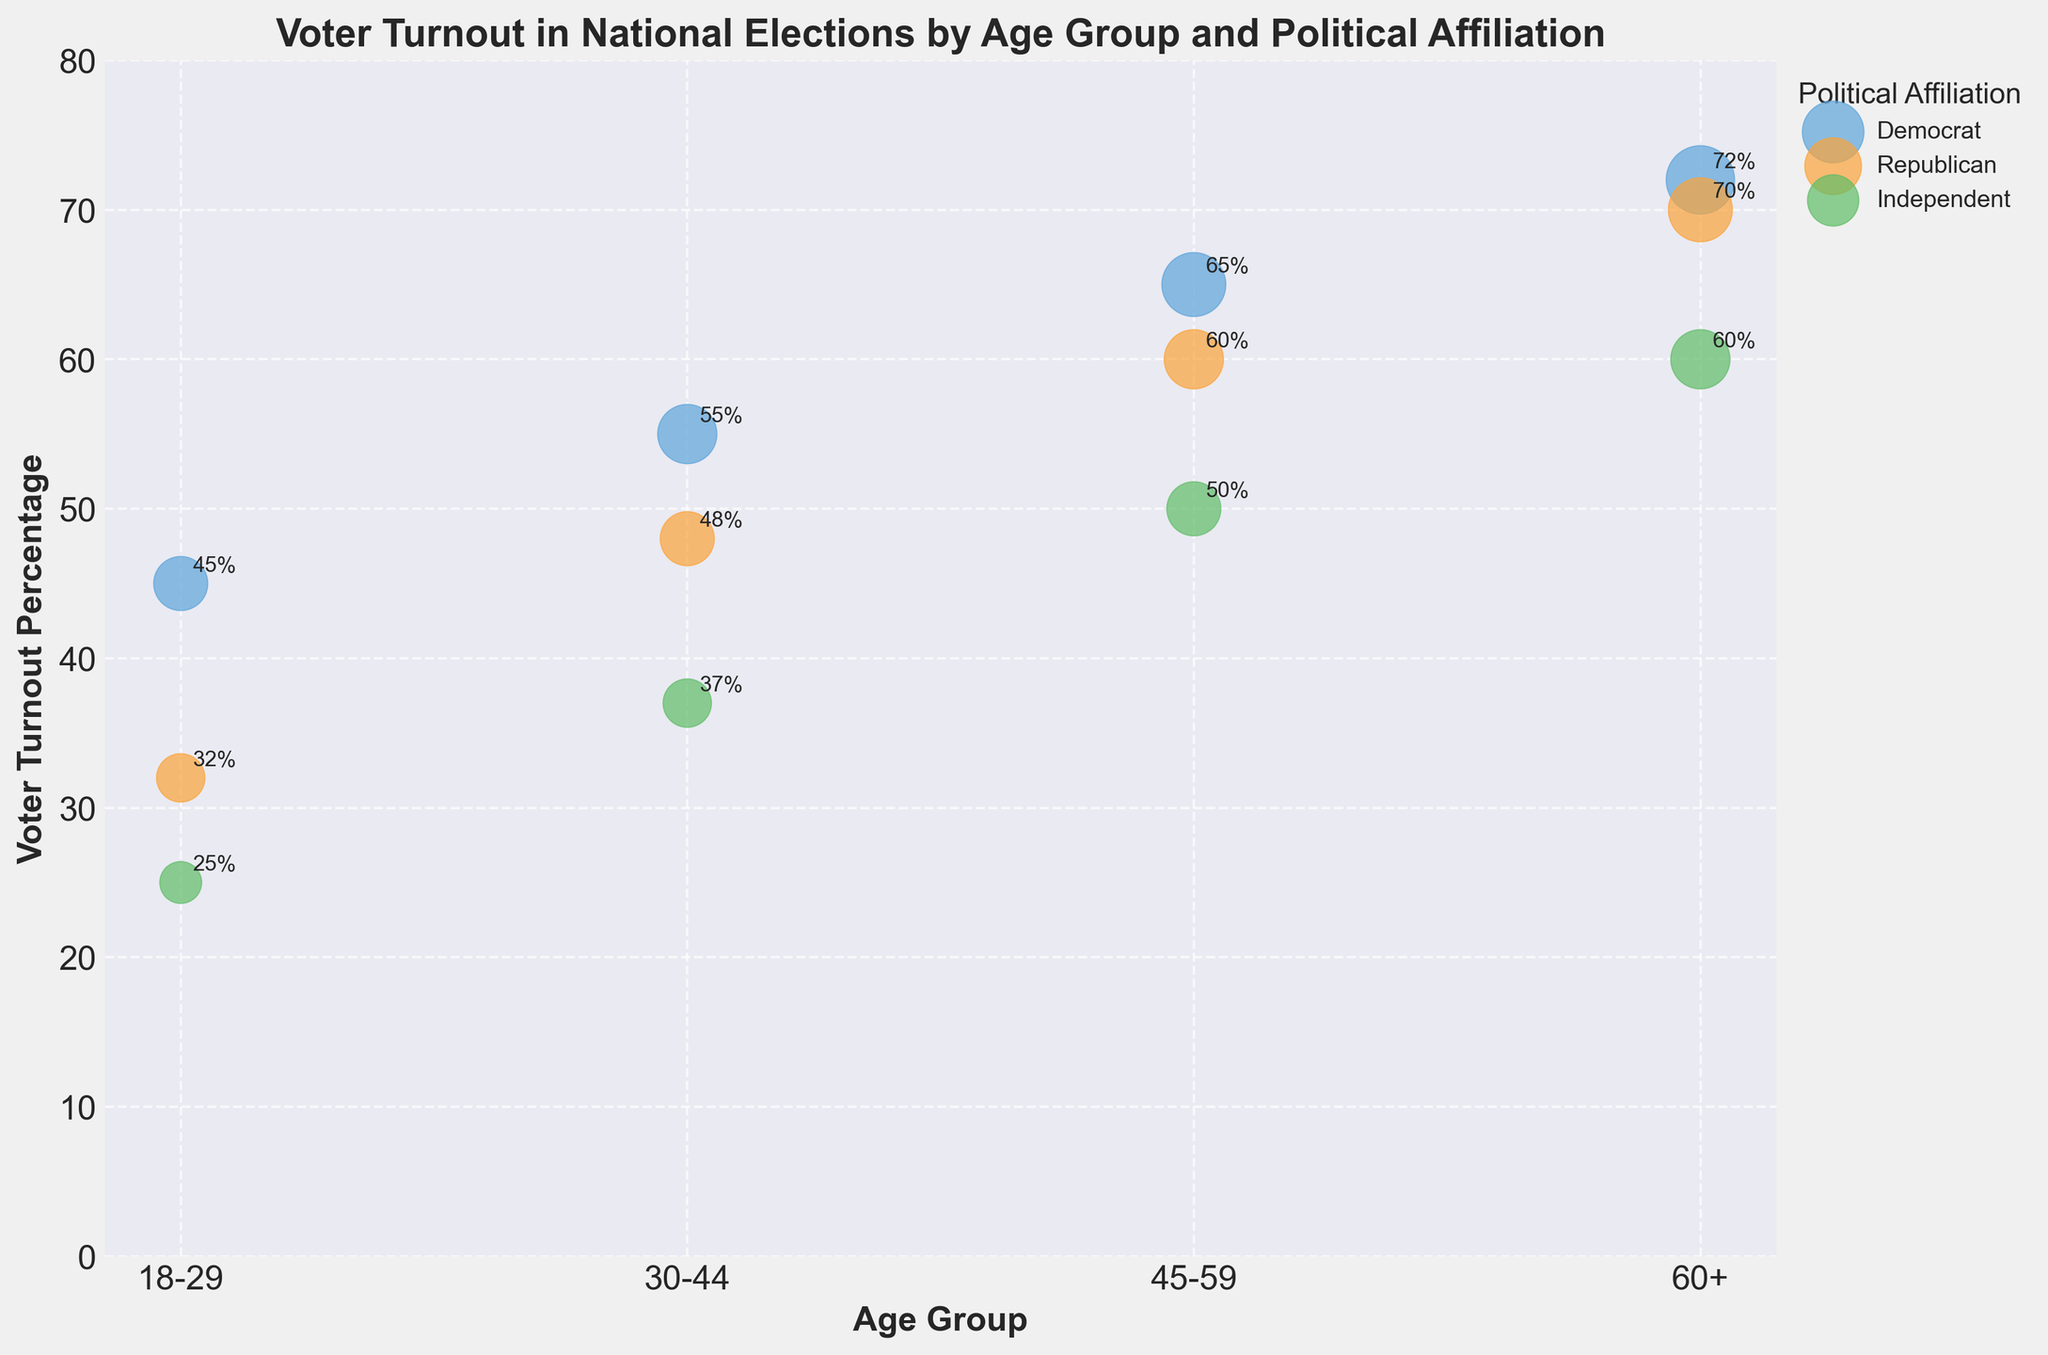What's the title of the figure? The title of the figure is displayed prominently at the top. It reads "Voter Turnout in National Elections by Age Group and Political Affiliation".
Answer: Voter Turnout in National Elections by Age Group and Political Affiliation What is the age group with the highest voter turnout percentage for Democrats? By looking at the y-axis and the color representing Democrats, the highest bubble appears in the 60+ age group with a voter turnout percentage of 72%.
Answer: 60+ Which political affiliation has the lowest voter turnout percentage in the 18-29 age group? Observing the bubbles in the 18-29 age group and noting their voter turnout percentages, the Independent affiliation has the smallest bubble with 25%.
Answer: Independent What's the difference in voter turnout percentage between Republicans and Independents in the 45-59 age group? The voter turnout percentage for Republicans in the 45-59 age group is 60% and for Independents, it is 50%. Subtracting these gives the difference: 60% - 50% = 10%.
Answer: 10% What color represents the Republican affiliation in the figure? Each political affiliation is represented by a different color. Republicans are represented by the color orange.
Answer: Orange Which age group has the smallest voter turnout bubble size for Democrats on the plot? Observing the bubble sizes for Democrats in all age groups, the smallest bubble size is 5, located in the 18-29 age group.
Answer: 18-29 Among all age groups, which political affiliation has the most consistent voter turnout percentage above 50%? By scanning the voter turnout percentages across each age group, Democrats consistently have voter turnout percentages above 50% across all age groups.
Answer: Democrat In the 30-44 age group, how much higher is the voter turnout percentage for Democrats compared to Independents? The voter turnout for Democrats in the 30-44 age group is 55% while for Independents, it is 37%. The difference is 55% - 37% = 18%.
Answer: 18% Which data point has the largest bubble size in the figure? The bubble size correlates with the numbers provided. The largest bubble size is 8, which corresponds to the 60+ age group for Democrats.
Answer: 60+ Democrats 